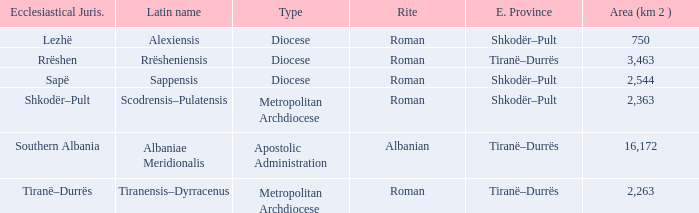What is Type for Rite Albanian? Apostolic Administration. 